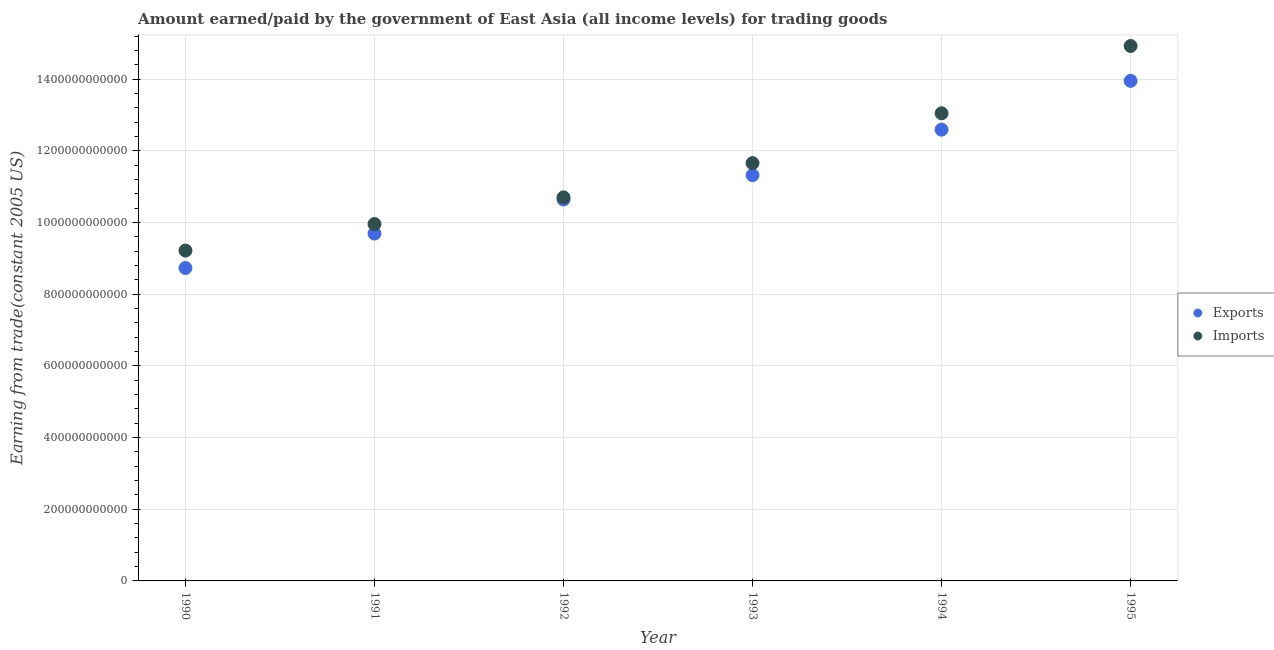Is the number of dotlines equal to the number of legend labels?
Offer a terse response. Yes. What is the amount earned from exports in 1993?
Provide a short and direct response. 1.13e+12. Across all years, what is the maximum amount paid for imports?
Ensure brevity in your answer.  1.49e+12. Across all years, what is the minimum amount earned from exports?
Offer a terse response. 8.73e+11. What is the total amount earned from exports in the graph?
Your answer should be very brief. 6.69e+12. What is the difference between the amount paid for imports in 1990 and that in 1994?
Keep it short and to the point. -3.83e+11. What is the difference between the amount earned from exports in 1993 and the amount paid for imports in 1990?
Offer a terse response. 2.11e+11. What is the average amount paid for imports per year?
Offer a terse response. 1.16e+12. In the year 1991, what is the difference between the amount paid for imports and amount earned from exports?
Your answer should be very brief. 2.66e+1. What is the ratio of the amount paid for imports in 1991 to that in 1992?
Keep it short and to the point. 0.93. What is the difference between the highest and the second highest amount paid for imports?
Keep it short and to the point. 1.88e+11. What is the difference between the highest and the lowest amount earned from exports?
Your response must be concise. 5.22e+11. Does the amount earned from exports monotonically increase over the years?
Provide a succinct answer. Yes. Is the amount earned from exports strictly less than the amount paid for imports over the years?
Provide a succinct answer. Yes. What is the difference between two consecutive major ticks on the Y-axis?
Your answer should be compact. 2.00e+11. Are the values on the major ticks of Y-axis written in scientific E-notation?
Keep it short and to the point. No. Does the graph contain any zero values?
Your response must be concise. No. Does the graph contain grids?
Make the answer very short. Yes. Where does the legend appear in the graph?
Give a very brief answer. Center right. How are the legend labels stacked?
Provide a short and direct response. Vertical. What is the title of the graph?
Provide a succinct answer. Amount earned/paid by the government of East Asia (all income levels) for trading goods. Does "Foreign liabilities" appear as one of the legend labels in the graph?
Give a very brief answer. No. What is the label or title of the X-axis?
Make the answer very short. Year. What is the label or title of the Y-axis?
Offer a very short reply. Earning from trade(constant 2005 US). What is the Earning from trade(constant 2005 US) in Exports in 1990?
Make the answer very short. 8.73e+11. What is the Earning from trade(constant 2005 US) in Imports in 1990?
Your response must be concise. 9.22e+11. What is the Earning from trade(constant 2005 US) in Exports in 1991?
Offer a terse response. 9.69e+11. What is the Earning from trade(constant 2005 US) in Imports in 1991?
Keep it short and to the point. 9.96e+11. What is the Earning from trade(constant 2005 US) in Exports in 1992?
Provide a succinct answer. 1.06e+12. What is the Earning from trade(constant 2005 US) in Imports in 1992?
Give a very brief answer. 1.07e+12. What is the Earning from trade(constant 2005 US) of Exports in 1993?
Offer a very short reply. 1.13e+12. What is the Earning from trade(constant 2005 US) of Imports in 1993?
Provide a succinct answer. 1.17e+12. What is the Earning from trade(constant 2005 US) of Exports in 1994?
Offer a terse response. 1.26e+12. What is the Earning from trade(constant 2005 US) in Imports in 1994?
Give a very brief answer. 1.30e+12. What is the Earning from trade(constant 2005 US) of Exports in 1995?
Provide a short and direct response. 1.40e+12. What is the Earning from trade(constant 2005 US) of Imports in 1995?
Your answer should be compact. 1.49e+12. Across all years, what is the maximum Earning from trade(constant 2005 US) of Exports?
Provide a short and direct response. 1.40e+12. Across all years, what is the maximum Earning from trade(constant 2005 US) in Imports?
Provide a short and direct response. 1.49e+12. Across all years, what is the minimum Earning from trade(constant 2005 US) in Exports?
Make the answer very short. 8.73e+11. Across all years, what is the minimum Earning from trade(constant 2005 US) in Imports?
Ensure brevity in your answer.  9.22e+11. What is the total Earning from trade(constant 2005 US) in Exports in the graph?
Make the answer very short. 6.69e+12. What is the total Earning from trade(constant 2005 US) of Imports in the graph?
Make the answer very short. 6.95e+12. What is the difference between the Earning from trade(constant 2005 US) in Exports in 1990 and that in 1991?
Your answer should be compact. -9.61e+1. What is the difference between the Earning from trade(constant 2005 US) of Imports in 1990 and that in 1991?
Keep it short and to the point. -7.40e+1. What is the difference between the Earning from trade(constant 2005 US) of Exports in 1990 and that in 1992?
Your answer should be very brief. -1.91e+11. What is the difference between the Earning from trade(constant 2005 US) in Imports in 1990 and that in 1992?
Your answer should be compact. -1.48e+11. What is the difference between the Earning from trade(constant 2005 US) of Exports in 1990 and that in 1993?
Keep it short and to the point. -2.59e+11. What is the difference between the Earning from trade(constant 2005 US) of Imports in 1990 and that in 1993?
Provide a succinct answer. -2.44e+11. What is the difference between the Earning from trade(constant 2005 US) of Exports in 1990 and that in 1994?
Your response must be concise. -3.86e+11. What is the difference between the Earning from trade(constant 2005 US) in Imports in 1990 and that in 1994?
Keep it short and to the point. -3.83e+11. What is the difference between the Earning from trade(constant 2005 US) in Exports in 1990 and that in 1995?
Give a very brief answer. -5.22e+11. What is the difference between the Earning from trade(constant 2005 US) of Imports in 1990 and that in 1995?
Your answer should be very brief. -5.71e+11. What is the difference between the Earning from trade(constant 2005 US) of Exports in 1991 and that in 1992?
Make the answer very short. -9.51e+1. What is the difference between the Earning from trade(constant 2005 US) of Imports in 1991 and that in 1992?
Make the answer very short. -7.45e+1. What is the difference between the Earning from trade(constant 2005 US) of Exports in 1991 and that in 1993?
Provide a short and direct response. -1.63e+11. What is the difference between the Earning from trade(constant 2005 US) in Imports in 1991 and that in 1993?
Give a very brief answer. -1.70e+11. What is the difference between the Earning from trade(constant 2005 US) in Exports in 1991 and that in 1994?
Your answer should be very brief. -2.90e+11. What is the difference between the Earning from trade(constant 2005 US) in Imports in 1991 and that in 1994?
Offer a terse response. -3.09e+11. What is the difference between the Earning from trade(constant 2005 US) of Exports in 1991 and that in 1995?
Ensure brevity in your answer.  -4.26e+11. What is the difference between the Earning from trade(constant 2005 US) of Imports in 1991 and that in 1995?
Provide a short and direct response. -4.97e+11. What is the difference between the Earning from trade(constant 2005 US) in Exports in 1992 and that in 1993?
Make the answer very short. -6.80e+1. What is the difference between the Earning from trade(constant 2005 US) in Imports in 1992 and that in 1993?
Keep it short and to the point. -9.56e+1. What is the difference between the Earning from trade(constant 2005 US) of Exports in 1992 and that in 1994?
Give a very brief answer. -1.95e+11. What is the difference between the Earning from trade(constant 2005 US) of Imports in 1992 and that in 1994?
Ensure brevity in your answer.  -2.35e+11. What is the difference between the Earning from trade(constant 2005 US) in Exports in 1992 and that in 1995?
Your answer should be very brief. -3.31e+11. What is the difference between the Earning from trade(constant 2005 US) of Imports in 1992 and that in 1995?
Your answer should be compact. -4.22e+11. What is the difference between the Earning from trade(constant 2005 US) of Exports in 1993 and that in 1994?
Offer a very short reply. -1.27e+11. What is the difference between the Earning from trade(constant 2005 US) in Imports in 1993 and that in 1994?
Provide a succinct answer. -1.39e+11. What is the difference between the Earning from trade(constant 2005 US) in Exports in 1993 and that in 1995?
Your response must be concise. -2.63e+11. What is the difference between the Earning from trade(constant 2005 US) of Imports in 1993 and that in 1995?
Make the answer very short. -3.27e+11. What is the difference between the Earning from trade(constant 2005 US) in Exports in 1994 and that in 1995?
Your answer should be compact. -1.36e+11. What is the difference between the Earning from trade(constant 2005 US) in Imports in 1994 and that in 1995?
Give a very brief answer. -1.88e+11. What is the difference between the Earning from trade(constant 2005 US) of Exports in 1990 and the Earning from trade(constant 2005 US) of Imports in 1991?
Ensure brevity in your answer.  -1.23e+11. What is the difference between the Earning from trade(constant 2005 US) of Exports in 1990 and the Earning from trade(constant 2005 US) of Imports in 1992?
Your answer should be very brief. -1.97e+11. What is the difference between the Earning from trade(constant 2005 US) of Exports in 1990 and the Earning from trade(constant 2005 US) of Imports in 1993?
Make the answer very short. -2.93e+11. What is the difference between the Earning from trade(constant 2005 US) in Exports in 1990 and the Earning from trade(constant 2005 US) in Imports in 1994?
Provide a short and direct response. -4.32e+11. What is the difference between the Earning from trade(constant 2005 US) in Exports in 1990 and the Earning from trade(constant 2005 US) in Imports in 1995?
Keep it short and to the point. -6.20e+11. What is the difference between the Earning from trade(constant 2005 US) in Exports in 1991 and the Earning from trade(constant 2005 US) in Imports in 1992?
Provide a succinct answer. -1.01e+11. What is the difference between the Earning from trade(constant 2005 US) of Exports in 1991 and the Earning from trade(constant 2005 US) of Imports in 1993?
Your response must be concise. -1.97e+11. What is the difference between the Earning from trade(constant 2005 US) of Exports in 1991 and the Earning from trade(constant 2005 US) of Imports in 1994?
Offer a terse response. -3.36e+11. What is the difference between the Earning from trade(constant 2005 US) in Exports in 1991 and the Earning from trade(constant 2005 US) in Imports in 1995?
Ensure brevity in your answer.  -5.23e+11. What is the difference between the Earning from trade(constant 2005 US) of Exports in 1992 and the Earning from trade(constant 2005 US) of Imports in 1993?
Provide a short and direct response. -1.02e+11. What is the difference between the Earning from trade(constant 2005 US) of Exports in 1992 and the Earning from trade(constant 2005 US) of Imports in 1994?
Your response must be concise. -2.41e+11. What is the difference between the Earning from trade(constant 2005 US) of Exports in 1992 and the Earning from trade(constant 2005 US) of Imports in 1995?
Ensure brevity in your answer.  -4.28e+11. What is the difference between the Earning from trade(constant 2005 US) in Exports in 1993 and the Earning from trade(constant 2005 US) in Imports in 1994?
Provide a short and direct response. -1.73e+11. What is the difference between the Earning from trade(constant 2005 US) in Exports in 1993 and the Earning from trade(constant 2005 US) in Imports in 1995?
Give a very brief answer. -3.60e+11. What is the difference between the Earning from trade(constant 2005 US) in Exports in 1994 and the Earning from trade(constant 2005 US) in Imports in 1995?
Provide a succinct answer. -2.33e+11. What is the average Earning from trade(constant 2005 US) of Exports per year?
Offer a terse response. 1.12e+12. What is the average Earning from trade(constant 2005 US) in Imports per year?
Give a very brief answer. 1.16e+12. In the year 1990, what is the difference between the Earning from trade(constant 2005 US) in Exports and Earning from trade(constant 2005 US) in Imports?
Offer a very short reply. -4.86e+1. In the year 1991, what is the difference between the Earning from trade(constant 2005 US) of Exports and Earning from trade(constant 2005 US) of Imports?
Your answer should be compact. -2.66e+1. In the year 1992, what is the difference between the Earning from trade(constant 2005 US) in Exports and Earning from trade(constant 2005 US) in Imports?
Your answer should be compact. -5.95e+09. In the year 1993, what is the difference between the Earning from trade(constant 2005 US) of Exports and Earning from trade(constant 2005 US) of Imports?
Make the answer very short. -3.36e+1. In the year 1994, what is the difference between the Earning from trade(constant 2005 US) in Exports and Earning from trade(constant 2005 US) in Imports?
Provide a short and direct response. -4.57e+1. In the year 1995, what is the difference between the Earning from trade(constant 2005 US) of Exports and Earning from trade(constant 2005 US) of Imports?
Keep it short and to the point. -9.74e+1. What is the ratio of the Earning from trade(constant 2005 US) in Exports in 1990 to that in 1991?
Your answer should be very brief. 0.9. What is the ratio of the Earning from trade(constant 2005 US) of Imports in 1990 to that in 1991?
Make the answer very short. 0.93. What is the ratio of the Earning from trade(constant 2005 US) in Exports in 1990 to that in 1992?
Ensure brevity in your answer.  0.82. What is the ratio of the Earning from trade(constant 2005 US) of Imports in 1990 to that in 1992?
Give a very brief answer. 0.86. What is the ratio of the Earning from trade(constant 2005 US) in Exports in 1990 to that in 1993?
Your response must be concise. 0.77. What is the ratio of the Earning from trade(constant 2005 US) in Imports in 1990 to that in 1993?
Provide a short and direct response. 0.79. What is the ratio of the Earning from trade(constant 2005 US) in Exports in 1990 to that in 1994?
Your response must be concise. 0.69. What is the ratio of the Earning from trade(constant 2005 US) in Imports in 1990 to that in 1994?
Make the answer very short. 0.71. What is the ratio of the Earning from trade(constant 2005 US) of Exports in 1990 to that in 1995?
Give a very brief answer. 0.63. What is the ratio of the Earning from trade(constant 2005 US) in Imports in 1990 to that in 1995?
Your response must be concise. 0.62. What is the ratio of the Earning from trade(constant 2005 US) of Exports in 1991 to that in 1992?
Make the answer very short. 0.91. What is the ratio of the Earning from trade(constant 2005 US) in Imports in 1991 to that in 1992?
Make the answer very short. 0.93. What is the ratio of the Earning from trade(constant 2005 US) of Exports in 1991 to that in 1993?
Your answer should be very brief. 0.86. What is the ratio of the Earning from trade(constant 2005 US) of Imports in 1991 to that in 1993?
Your answer should be very brief. 0.85. What is the ratio of the Earning from trade(constant 2005 US) in Exports in 1991 to that in 1994?
Give a very brief answer. 0.77. What is the ratio of the Earning from trade(constant 2005 US) of Imports in 1991 to that in 1994?
Give a very brief answer. 0.76. What is the ratio of the Earning from trade(constant 2005 US) in Exports in 1991 to that in 1995?
Your response must be concise. 0.69. What is the ratio of the Earning from trade(constant 2005 US) of Imports in 1991 to that in 1995?
Your answer should be compact. 0.67. What is the ratio of the Earning from trade(constant 2005 US) in Exports in 1992 to that in 1993?
Provide a succinct answer. 0.94. What is the ratio of the Earning from trade(constant 2005 US) of Imports in 1992 to that in 1993?
Offer a very short reply. 0.92. What is the ratio of the Earning from trade(constant 2005 US) of Exports in 1992 to that in 1994?
Give a very brief answer. 0.85. What is the ratio of the Earning from trade(constant 2005 US) of Imports in 1992 to that in 1994?
Provide a short and direct response. 0.82. What is the ratio of the Earning from trade(constant 2005 US) of Exports in 1992 to that in 1995?
Ensure brevity in your answer.  0.76. What is the ratio of the Earning from trade(constant 2005 US) in Imports in 1992 to that in 1995?
Offer a very short reply. 0.72. What is the ratio of the Earning from trade(constant 2005 US) in Exports in 1993 to that in 1994?
Offer a terse response. 0.9. What is the ratio of the Earning from trade(constant 2005 US) in Imports in 1993 to that in 1994?
Your response must be concise. 0.89. What is the ratio of the Earning from trade(constant 2005 US) of Exports in 1993 to that in 1995?
Your answer should be compact. 0.81. What is the ratio of the Earning from trade(constant 2005 US) of Imports in 1993 to that in 1995?
Offer a very short reply. 0.78. What is the ratio of the Earning from trade(constant 2005 US) in Exports in 1994 to that in 1995?
Make the answer very short. 0.9. What is the ratio of the Earning from trade(constant 2005 US) of Imports in 1994 to that in 1995?
Your response must be concise. 0.87. What is the difference between the highest and the second highest Earning from trade(constant 2005 US) in Exports?
Provide a short and direct response. 1.36e+11. What is the difference between the highest and the second highest Earning from trade(constant 2005 US) in Imports?
Offer a terse response. 1.88e+11. What is the difference between the highest and the lowest Earning from trade(constant 2005 US) of Exports?
Provide a short and direct response. 5.22e+11. What is the difference between the highest and the lowest Earning from trade(constant 2005 US) in Imports?
Your answer should be compact. 5.71e+11. 